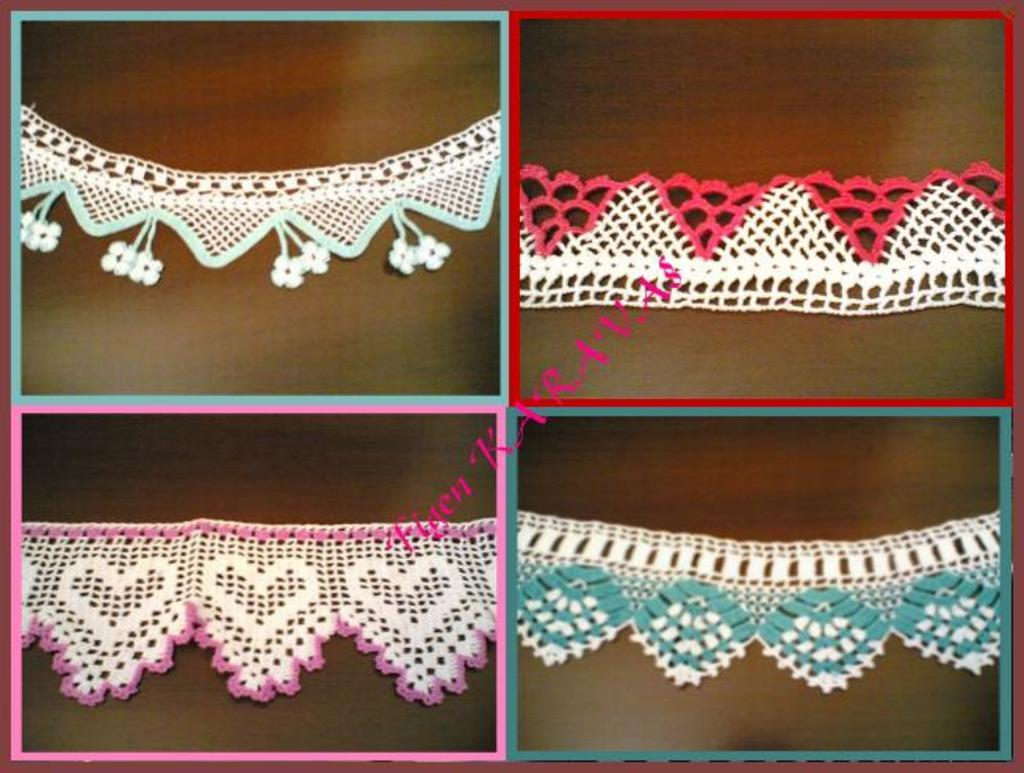What type of objects can be seen in the image? There are crochets in the image. Is there any text present in the image? Yes, there is text visible in the image. Reasoning: Let' Let's think step by step in order to produce the conversation. We start by identifying the main subjects in the image, which are the crochets. Then, we mention the presence of text in the image, as stated in the facts. We avoid yes/no questions and ensure that the language is simple and clear. Absurd Question/Answer: Can you tell me how many guns are depicted in the image? There are no guns present in the image; it features crochets and text. What type of caption is written on the crochets in the image? There is no caption written on the crochets in the image}. 